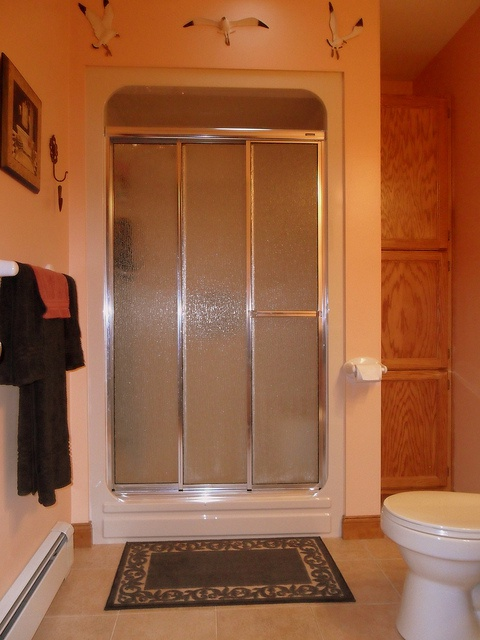Describe the objects in this image and their specific colors. I can see a toilet in brown, darkgray, tan, and gray tones in this image. 